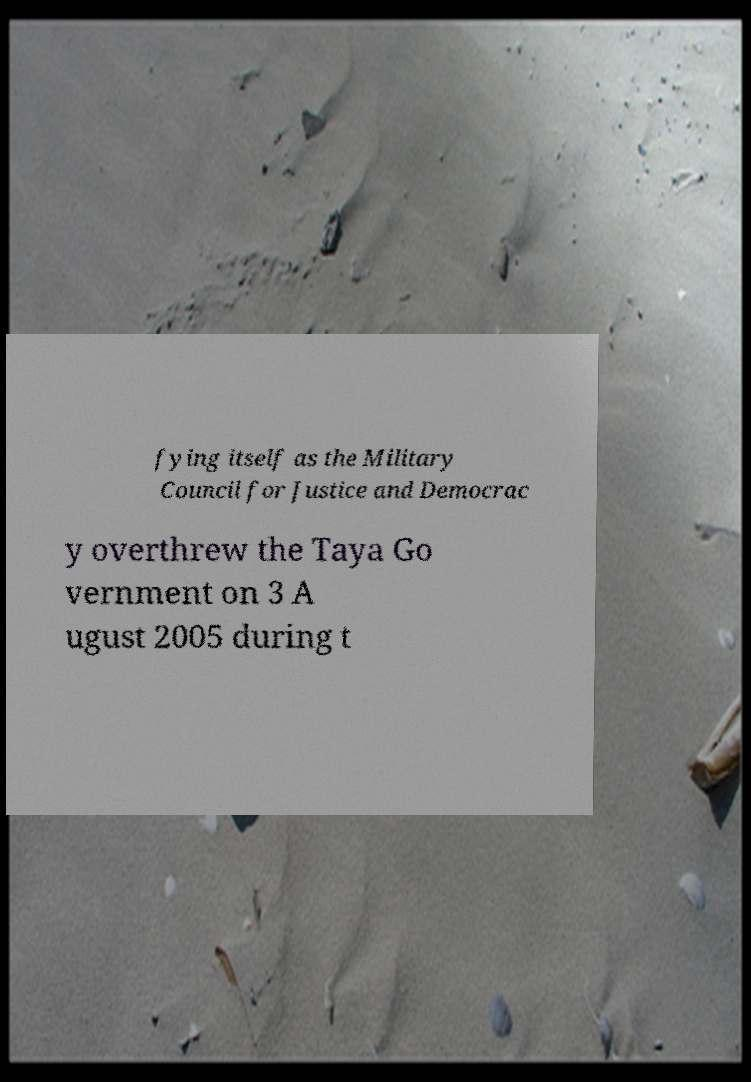Could you assist in decoding the text presented in this image and type it out clearly? fying itself as the Military Council for Justice and Democrac y overthrew the Taya Go vernment on 3 A ugust 2005 during t 